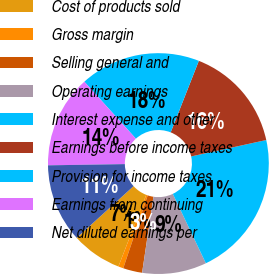Convert chart to OTSL. <chart><loc_0><loc_0><loc_500><loc_500><pie_chart><fcel>Cost of products sold<fcel>Gross margin<fcel>Selling general and<fcel>Operating earnings<fcel>Interest expense and other<fcel>Earnings before income taxes<fcel>Provision for income taxes<fcel>Earnings from continuing<fcel>Net diluted earnings per<nl><fcel>7.36%<fcel>0.74%<fcel>2.8%<fcel>9.43%<fcel>21.35%<fcel>15.61%<fcel>17.67%<fcel>13.55%<fcel>11.49%<nl></chart> 